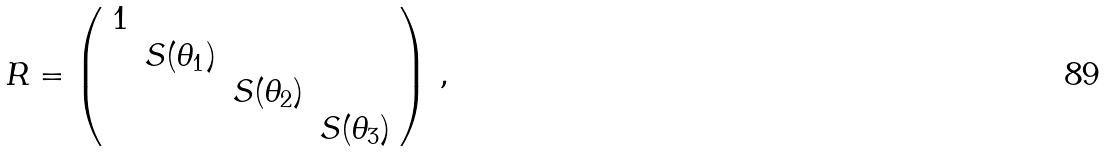<formula> <loc_0><loc_0><loc_500><loc_500>R = \left ( \begin{array} { c c c c } 1 & \, & \, & \, \\ \, & S ( \theta _ { 1 } ) & \, & \, \\ \, & \, & S ( \theta _ { 2 } ) & \, \\ \, & \, & \, & S ( \theta _ { 3 } ) \\ \end{array} \right ) \, ,</formula> 